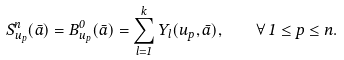Convert formula to latex. <formula><loc_0><loc_0><loc_500><loc_500>S ^ { n } _ { u _ { p } } ( \bar { a } ) = B ^ { 0 } _ { u _ { p } } ( \bar { a } ) = \sum _ { l = 1 } ^ { k } Y _ { l } ( u _ { p } , \bar { a } ) , \quad \forall \, 1 \leq p \leq n .</formula> 